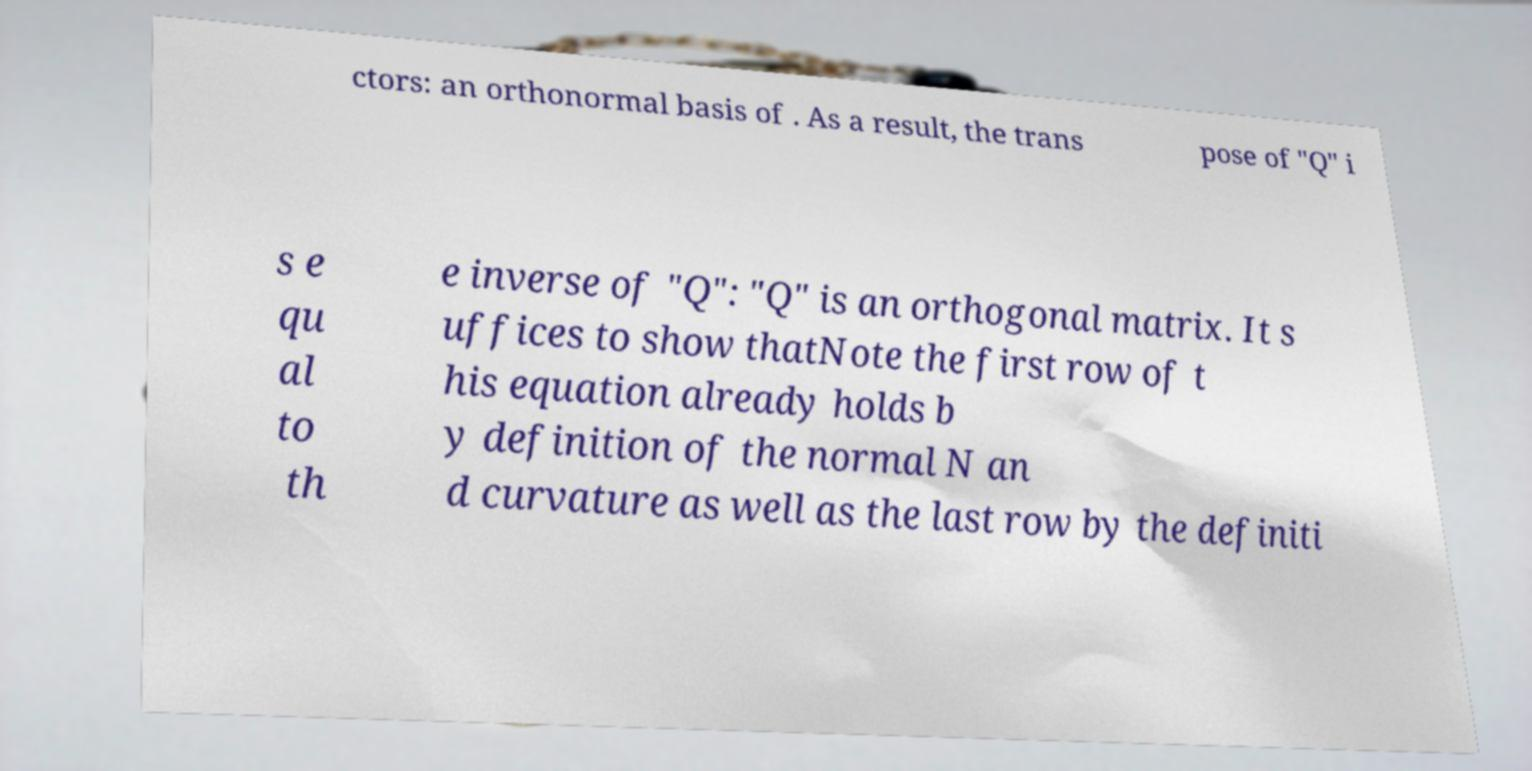Could you assist in decoding the text presented in this image and type it out clearly? ctors: an orthonormal basis of . As a result, the trans pose of "Q" i s e qu al to th e inverse of "Q": "Q" is an orthogonal matrix. It s uffices to show thatNote the first row of t his equation already holds b y definition of the normal N an d curvature as well as the last row by the definiti 